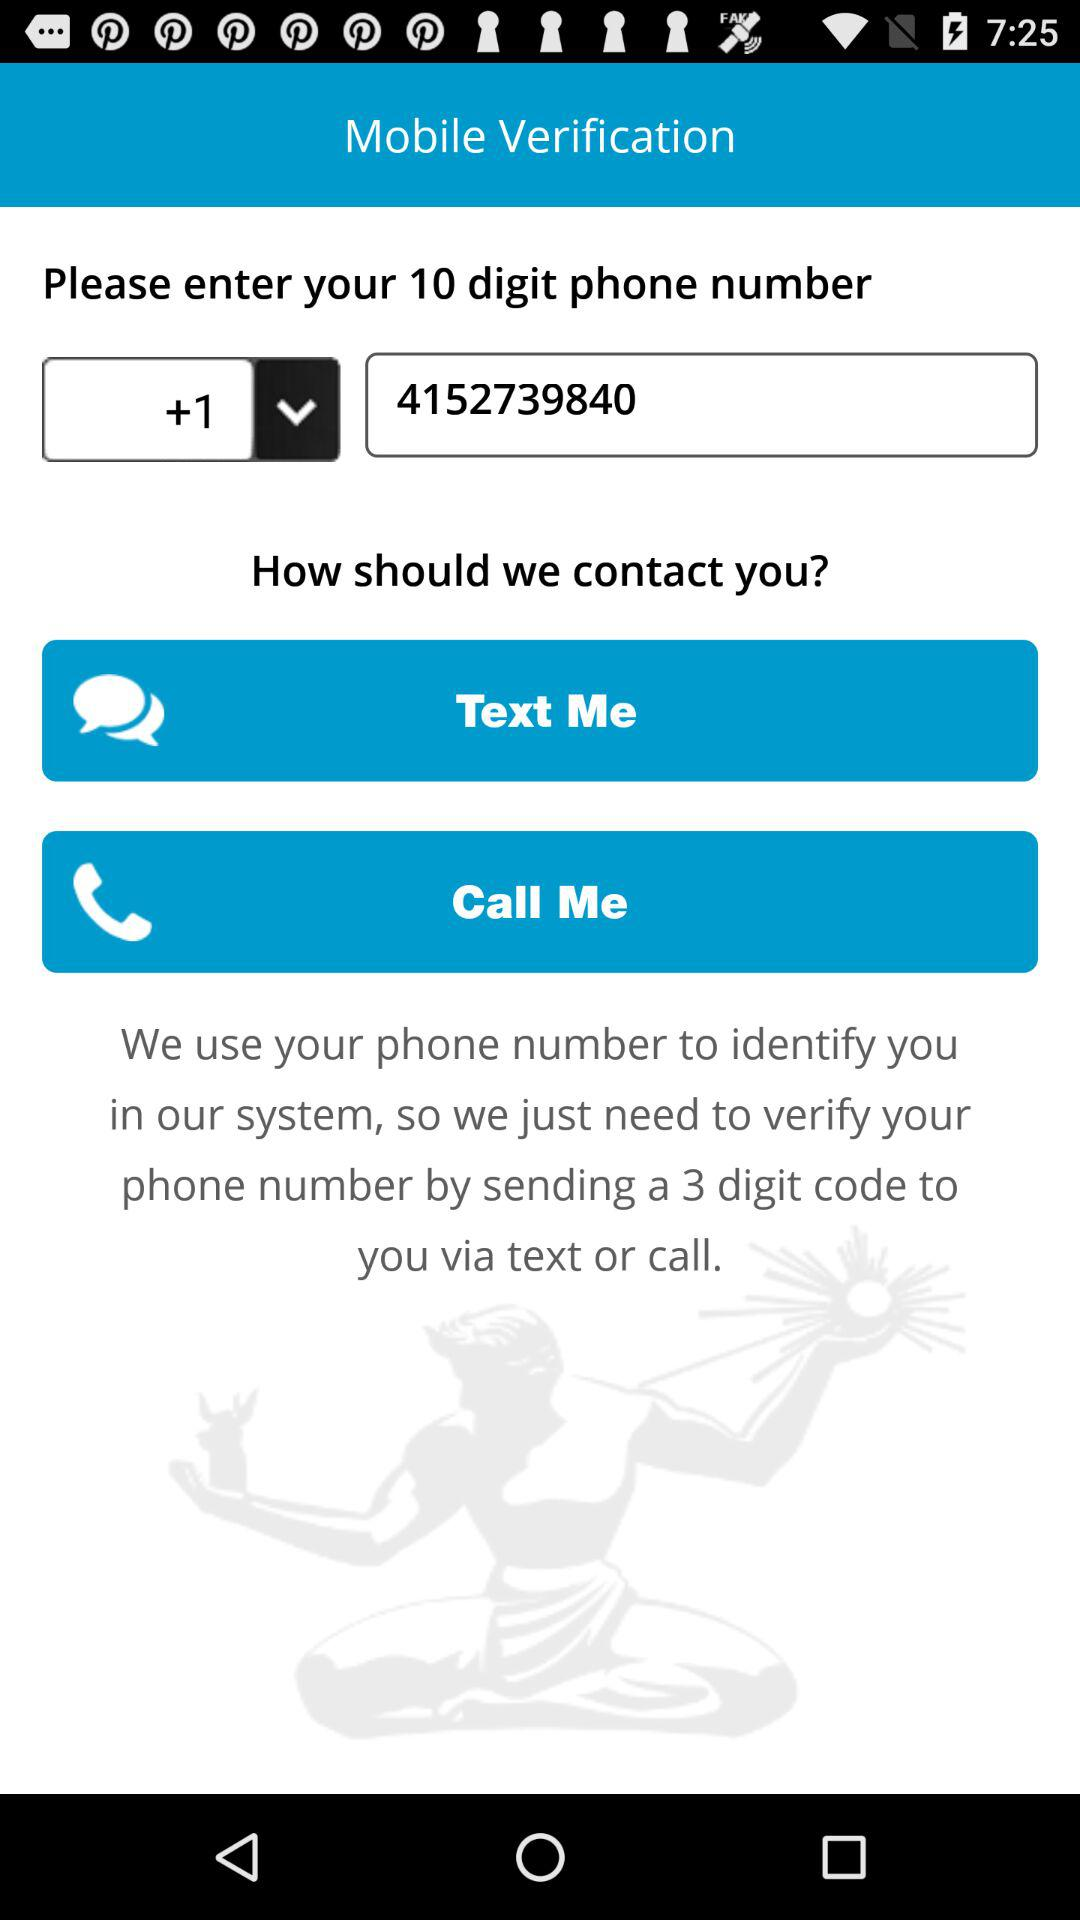What is the selected country code? The country code is +1. 